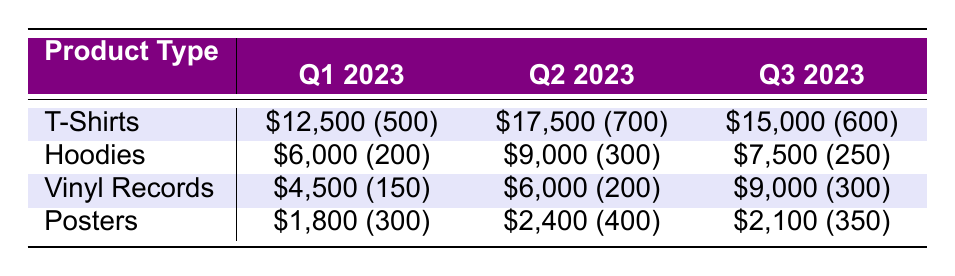What was the total revenue from T-Shirts sold in Q2 2023? In Q2 2023, T-Shirts generated a revenue of 17,500. This is a single data point from the table.
Answer: 17,500 How many units of Vinyl Records were sold across all time periods? To find the total units sold for Vinyl Records, we sum the units sold in each quarter: 150 (Q1) + 200 (Q2) + 300 (Q3) = 650.
Answer: 650 Did hoodie sales increase from Q1 2023 to Q3 2023? Hoodie sales were 6,000 in Q1 2023 and 7,500 in Q3 2023, indicating an increase of 1,500 in sales. Thus, the statement is true.
Answer: Yes What was the average revenue generated by Posters sold in Q1 2023 and Q3 2023? Revenue generated from posters in Q1 is 1,800, and in Q3 it is 2,100. To find the average, we calculate (1,800 + 2,100) / 2 = 1,950.
Answer: 1,950 Which product type had the highest unit sales in Q2 2023? In Q2 2023, T-Shirts had the highest unit sales of 700 compared to Hoodies (300), Vinyl Records (200), and Posters (400).
Answer: T-Shirts What was the revenue difference between Hoodies and Posters in Q3 2023? In Q3 2023, Hoodies generated 7,500 while Posters generated 2,100. To find the difference, we calculate 7,500 - 2,100 = 5,400.
Answer: 5,400 Is it true that more T-Shirts were sold in Q2 2023 than Vinyl Records in Q3 2023? In Q2 2023, T-Shirts sold 700, and in Q3 2023, Vinyl Records sold 300. Since 700 is greater than 300, this statement is true.
Answer: Yes What was the total revenue for all product types in Q1 2023? The revenues in Q1 2023 were: T-Shirts 12,500 + Hoodies 6,000 + Vinyl Records 4,500 + Posters 1,800 = 24,800.
Answer: 24,800 